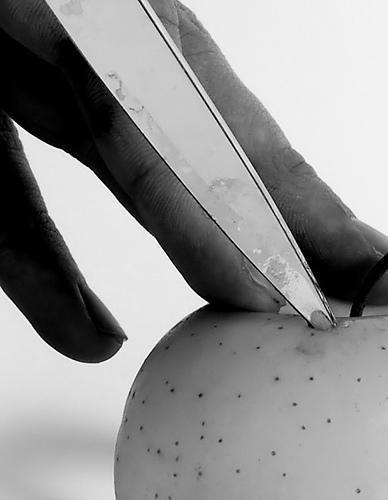Verify the accuracy of this image caption: "The person is touching the apple.".
Answer yes or no. Yes. 